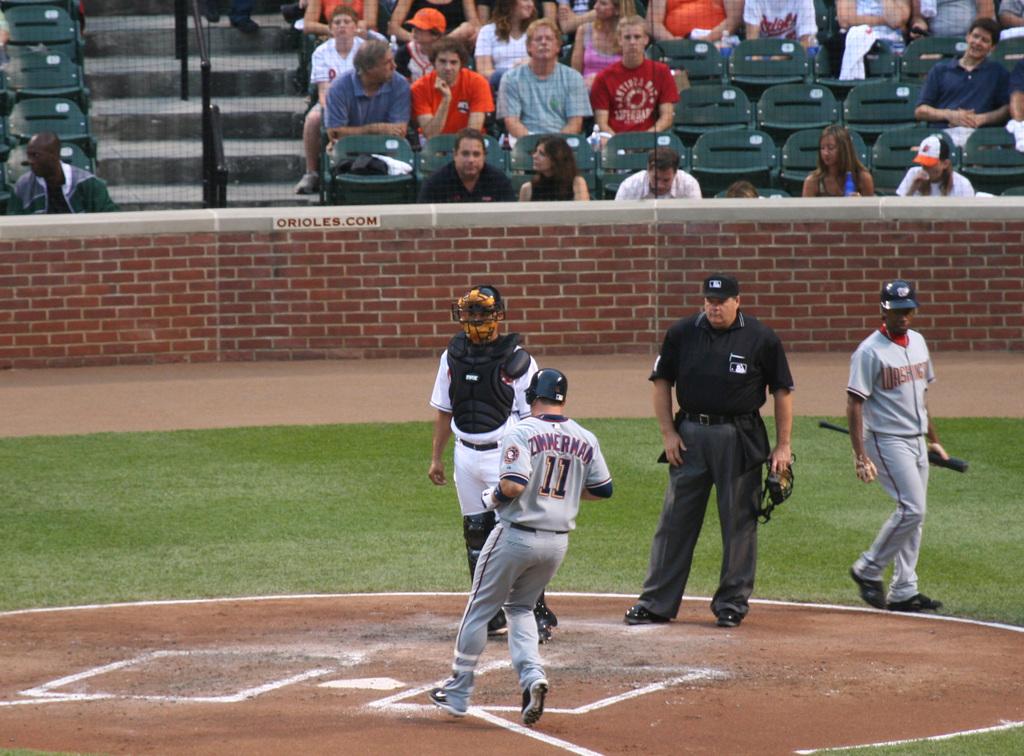What is zimmerman's jersey number?
Provide a succinct answer. 11. What team are these athletes from?
Ensure brevity in your answer.  Washington. 